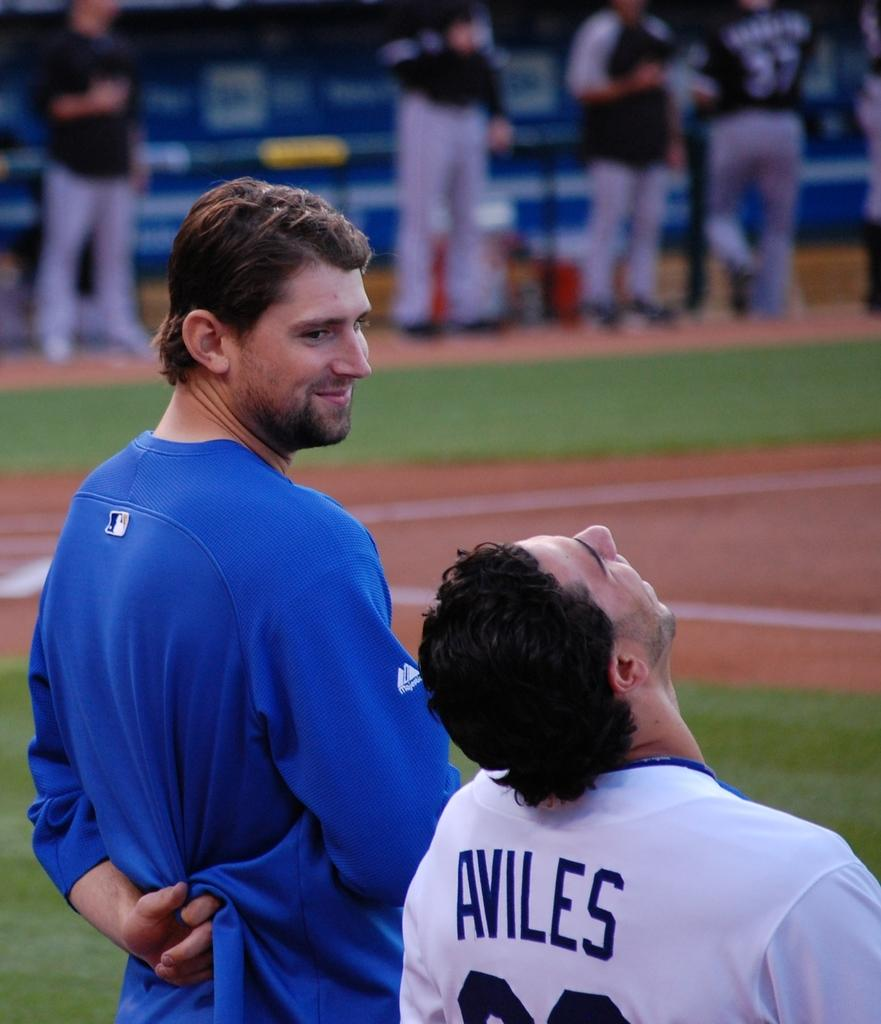Provide a one-sentence caption for the provided image. A baseball player named Aviles looking up at the sky. 